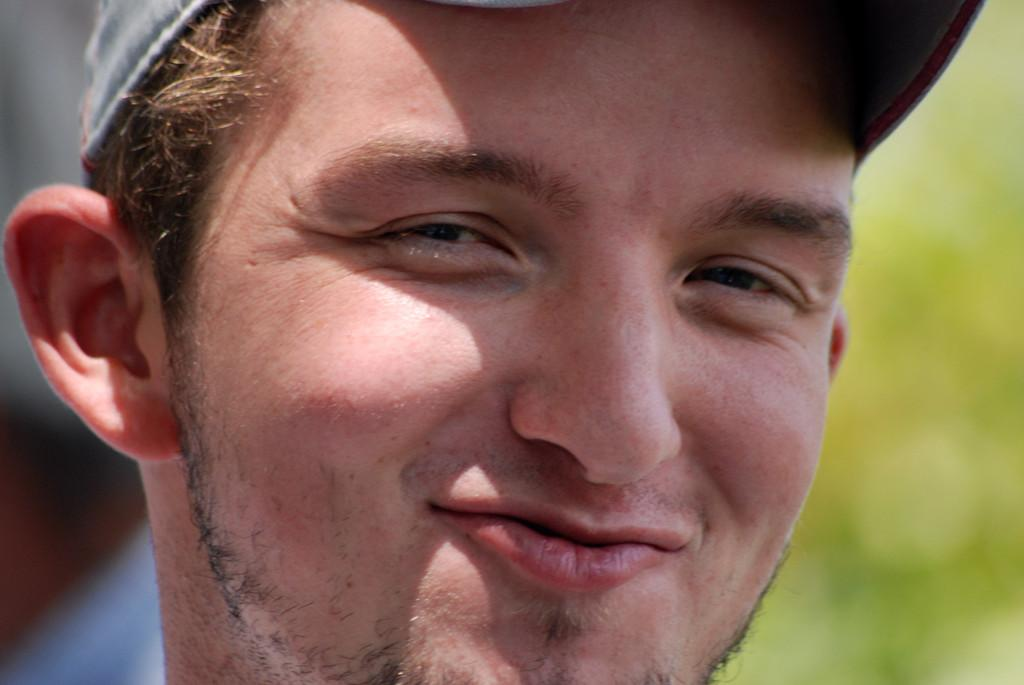What is the main subject of the image? There is a person's face in the image. What is the person wearing on their head? The person is wearing a cap. Can you describe the background of the image? The background of the image is blurry, and the colors include green, grey, brown, and blue. What type of fuel is the person using to power their emotions in the image? There is no indication in the image that the person is using any type of fuel to power their emotions. 